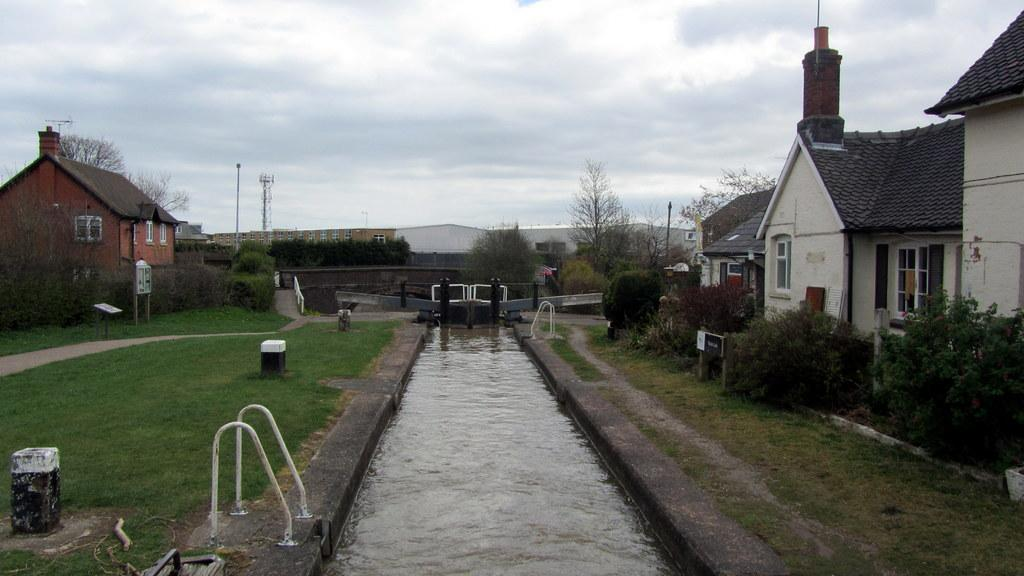What type of structures can be seen in the image? There are buildings with windows in the image. What natural elements are present in the image? There are trees, grass, and plants in the image. What type of barrier is visible in the image? There is a fence in the image. What type of vertical structures can be seen in the image? There are metal poles in the image. What type of landscape feature is visible in the image? There is water visible in the image. What type of tall structure is present in the image? There is a tower in the image. What is the condition of the sky in the image? The sky is visible in the image and appears cloudy. What type of plastic shape can be seen in the image? There is no plastic shape present in the image. What type of agreement is being made in the image? There is no agreement being made in the image; it is a scene with buildings, trees, grass, plants, a fence, metal poles, water, a tower, and a cloudy sky. 